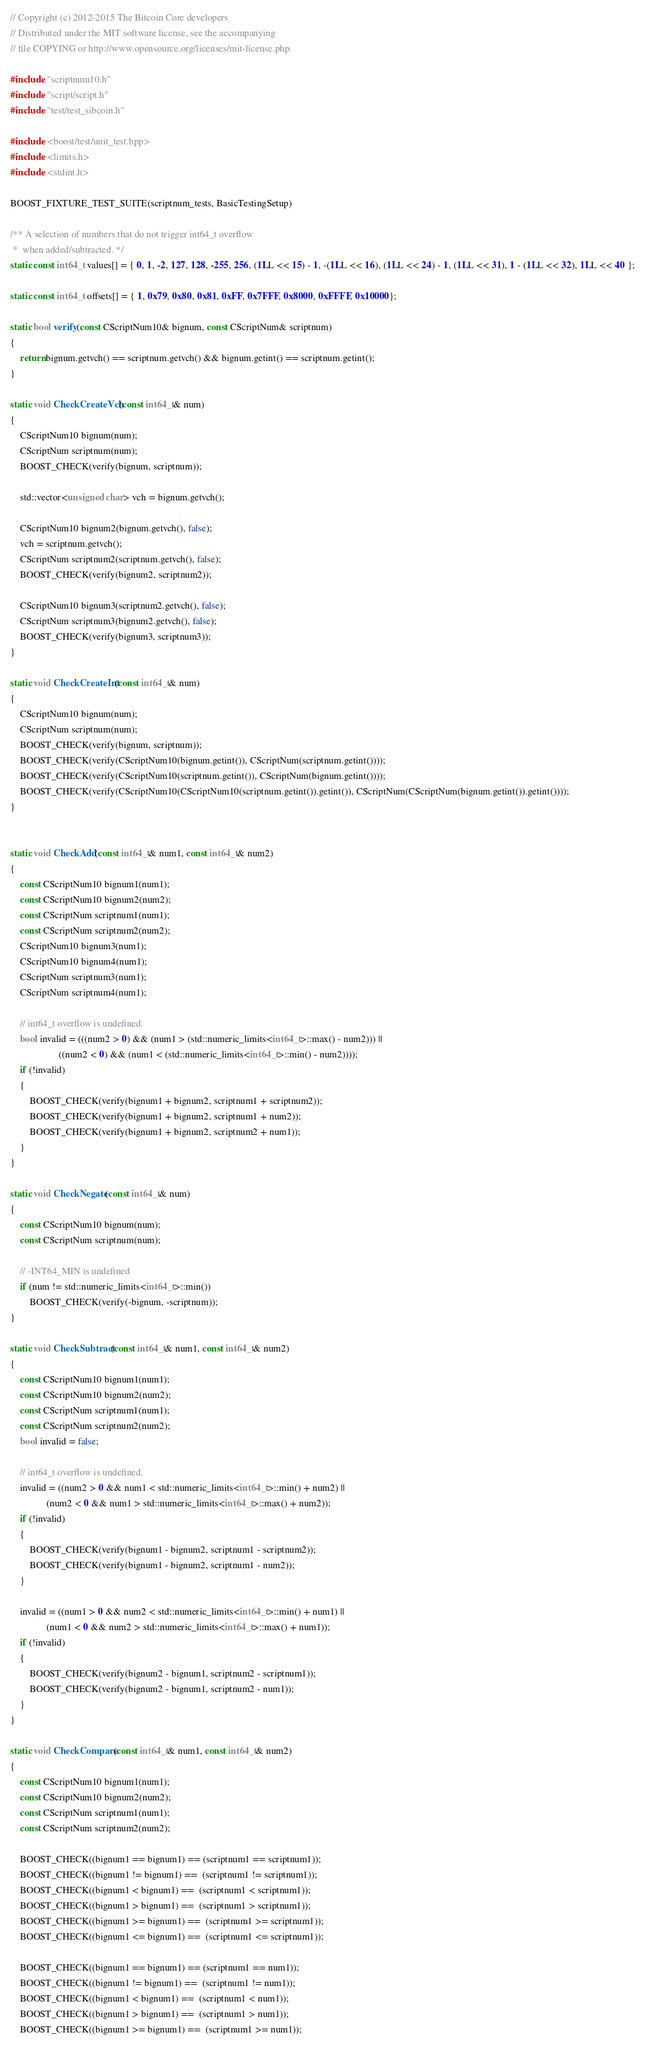<code> <loc_0><loc_0><loc_500><loc_500><_C++_>// Copyright (c) 2012-2015 The Bitcoin Core developers
// Distributed under the MIT software license, see the accompanying
// file COPYING or http://www.opensource.org/licenses/mit-license.php.

#include "scriptnum10.h"
#include "script/script.h"
#include "test/test_sibcoin.h"

#include <boost/test/unit_test.hpp>
#include <limits.h>
#include <stdint.h>

BOOST_FIXTURE_TEST_SUITE(scriptnum_tests, BasicTestingSetup)

/** A selection of numbers that do not trigger int64_t overflow
 *  when added/subtracted. */
static const int64_t values[] = { 0, 1, -2, 127, 128, -255, 256, (1LL << 15) - 1, -(1LL << 16), (1LL << 24) - 1, (1LL << 31), 1 - (1LL << 32), 1LL << 40 };

static const int64_t offsets[] = { 1, 0x79, 0x80, 0x81, 0xFF, 0x7FFF, 0x8000, 0xFFFF, 0x10000};

static bool verify(const CScriptNum10& bignum, const CScriptNum& scriptnum)
{
    return bignum.getvch() == scriptnum.getvch() && bignum.getint() == scriptnum.getint();
}

static void CheckCreateVch(const int64_t& num)
{
    CScriptNum10 bignum(num);
    CScriptNum scriptnum(num);
    BOOST_CHECK(verify(bignum, scriptnum));

    std::vector<unsigned char> vch = bignum.getvch();

    CScriptNum10 bignum2(bignum.getvch(), false);
    vch = scriptnum.getvch();
    CScriptNum scriptnum2(scriptnum.getvch(), false);
    BOOST_CHECK(verify(bignum2, scriptnum2));

    CScriptNum10 bignum3(scriptnum2.getvch(), false);
    CScriptNum scriptnum3(bignum2.getvch(), false);
    BOOST_CHECK(verify(bignum3, scriptnum3));
}

static void CheckCreateInt(const int64_t& num)
{
    CScriptNum10 bignum(num);
    CScriptNum scriptnum(num);
    BOOST_CHECK(verify(bignum, scriptnum));
    BOOST_CHECK(verify(CScriptNum10(bignum.getint()), CScriptNum(scriptnum.getint())));
    BOOST_CHECK(verify(CScriptNum10(scriptnum.getint()), CScriptNum(bignum.getint())));
    BOOST_CHECK(verify(CScriptNum10(CScriptNum10(scriptnum.getint()).getint()), CScriptNum(CScriptNum(bignum.getint()).getint())));
}


static void CheckAdd(const int64_t& num1, const int64_t& num2)
{
    const CScriptNum10 bignum1(num1);
    const CScriptNum10 bignum2(num2);
    const CScriptNum scriptnum1(num1);
    const CScriptNum scriptnum2(num2);
    CScriptNum10 bignum3(num1);
    CScriptNum10 bignum4(num1);
    CScriptNum scriptnum3(num1);
    CScriptNum scriptnum4(num1);

    // int64_t overflow is undefined.
    bool invalid = (((num2 > 0) && (num1 > (std::numeric_limits<int64_t>::max() - num2))) ||
                    ((num2 < 0) && (num1 < (std::numeric_limits<int64_t>::min() - num2))));
    if (!invalid)
    {
        BOOST_CHECK(verify(bignum1 + bignum2, scriptnum1 + scriptnum2));
        BOOST_CHECK(verify(bignum1 + bignum2, scriptnum1 + num2));
        BOOST_CHECK(verify(bignum1 + bignum2, scriptnum2 + num1));
    }
}

static void CheckNegate(const int64_t& num)
{
    const CScriptNum10 bignum(num);
    const CScriptNum scriptnum(num);

    // -INT64_MIN is undefined
    if (num != std::numeric_limits<int64_t>::min())
        BOOST_CHECK(verify(-bignum, -scriptnum));
}

static void CheckSubtract(const int64_t& num1, const int64_t& num2)
{
    const CScriptNum10 bignum1(num1);
    const CScriptNum10 bignum2(num2);
    const CScriptNum scriptnum1(num1);
    const CScriptNum scriptnum2(num2);
    bool invalid = false;

    // int64_t overflow is undefined.
    invalid = ((num2 > 0 && num1 < std::numeric_limits<int64_t>::min() + num2) ||
               (num2 < 0 && num1 > std::numeric_limits<int64_t>::max() + num2));
    if (!invalid)
    {
        BOOST_CHECK(verify(bignum1 - bignum2, scriptnum1 - scriptnum2));
        BOOST_CHECK(verify(bignum1 - bignum2, scriptnum1 - num2));
    }

    invalid = ((num1 > 0 && num2 < std::numeric_limits<int64_t>::min() + num1) ||
               (num1 < 0 && num2 > std::numeric_limits<int64_t>::max() + num1));
    if (!invalid)
    {
        BOOST_CHECK(verify(bignum2 - bignum1, scriptnum2 - scriptnum1));
        BOOST_CHECK(verify(bignum2 - bignum1, scriptnum2 - num1));
    }
}

static void CheckCompare(const int64_t& num1, const int64_t& num2)
{
    const CScriptNum10 bignum1(num1);
    const CScriptNum10 bignum2(num2);
    const CScriptNum scriptnum1(num1);
    const CScriptNum scriptnum2(num2);

    BOOST_CHECK((bignum1 == bignum1) == (scriptnum1 == scriptnum1));
    BOOST_CHECK((bignum1 != bignum1) ==  (scriptnum1 != scriptnum1));
    BOOST_CHECK((bignum1 < bignum1) ==  (scriptnum1 < scriptnum1));
    BOOST_CHECK((bignum1 > bignum1) ==  (scriptnum1 > scriptnum1));
    BOOST_CHECK((bignum1 >= bignum1) ==  (scriptnum1 >= scriptnum1));
    BOOST_CHECK((bignum1 <= bignum1) ==  (scriptnum1 <= scriptnum1));

    BOOST_CHECK((bignum1 == bignum1) == (scriptnum1 == num1));
    BOOST_CHECK((bignum1 != bignum1) ==  (scriptnum1 != num1));
    BOOST_CHECK((bignum1 < bignum1) ==  (scriptnum1 < num1));
    BOOST_CHECK((bignum1 > bignum1) ==  (scriptnum1 > num1));
    BOOST_CHECK((bignum1 >= bignum1) ==  (scriptnum1 >= num1));</code> 